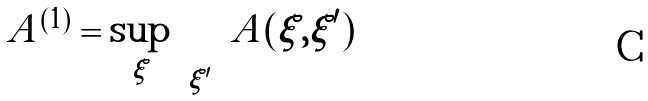Convert formula to latex. <formula><loc_0><loc_0><loc_500><loc_500>\| A \| ^ { ( 1 ) } = \sup _ { \xi } \sum _ { \xi ^ { \prime } } | A ( \xi , \xi ^ { \prime } ) |</formula> 